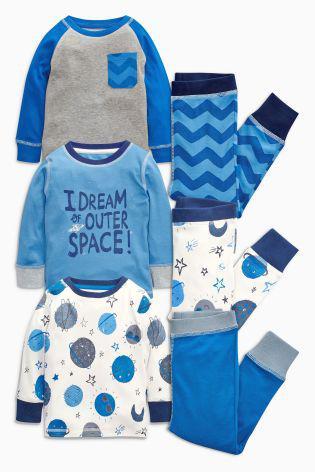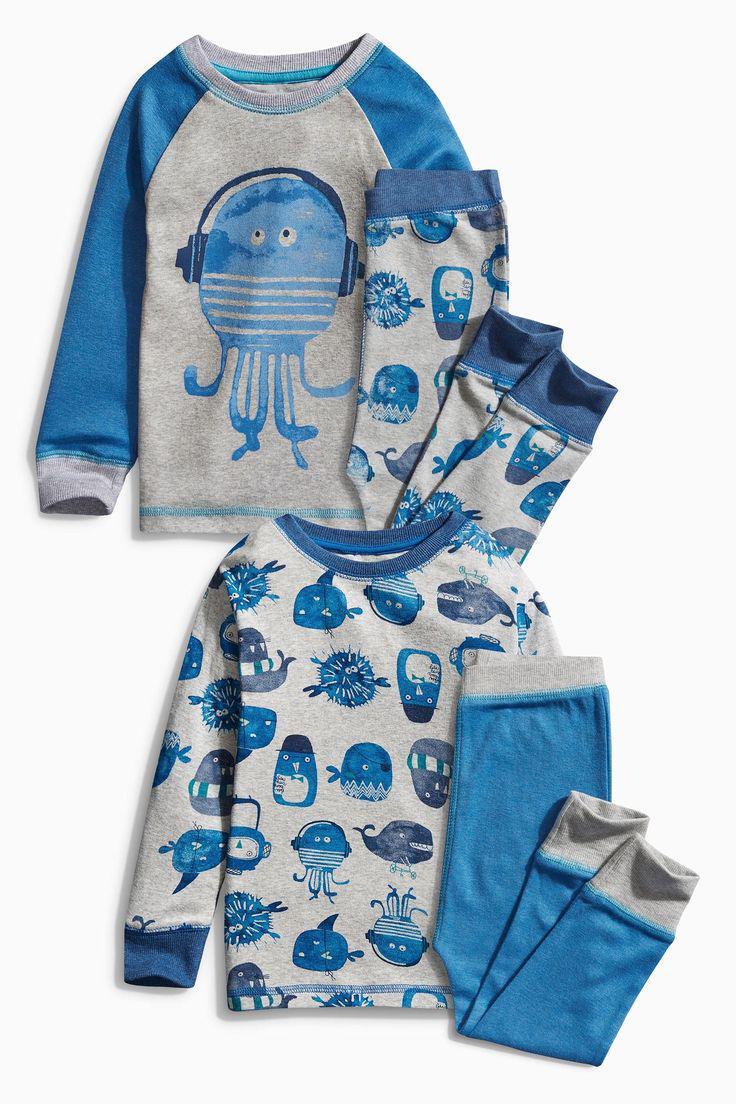The first image is the image on the left, the second image is the image on the right. Evaluate the accuracy of this statement regarding the images: "No individual image contains more than two sets of sleepwear, and the right image includes a pajama top depicting a cartoon train face.". Is it true? Answer yes or no. No. The first image is the image on the left, the second image is the image on the right. For the images shown, is this caption "There are two sets of pajamas in each of the images." true? Answer yes or no. No. 